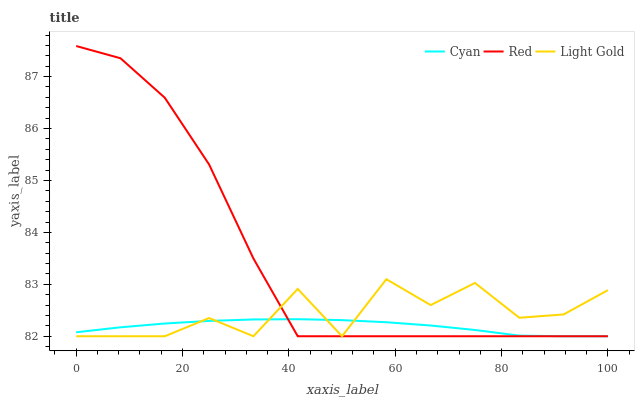Does Light Gold have the minimum area under the curve?
Answer yes or no. No. Does Light Gold have the maximum area under the curve?
Answer yes or no. No. Is Red the smoothest?
Answer yes or no. No. Is Red the roughest?
Answer yes or no. No. Does Light Gold have the highest value?
Answer yes or no. No. 